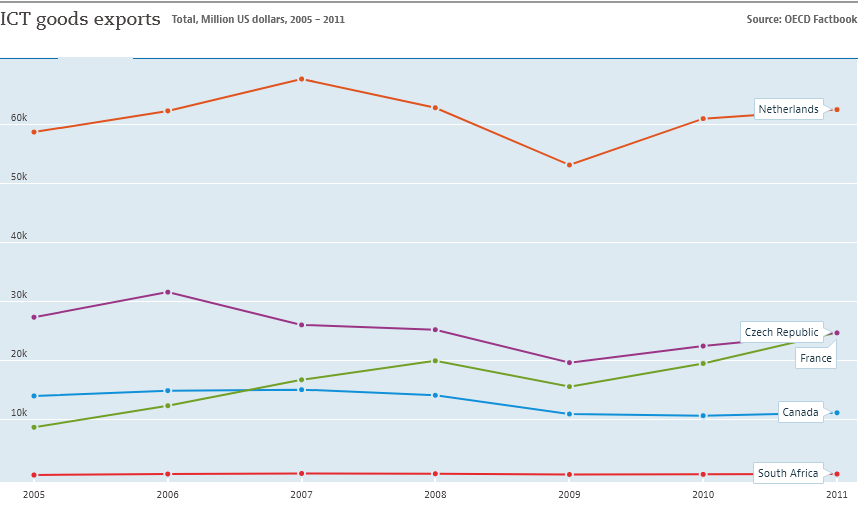Give some essential details in this illustration. The country represented by the blue color line is Canada. In 2007, the Netherlands recorded the highest level of ICT goods exports. 